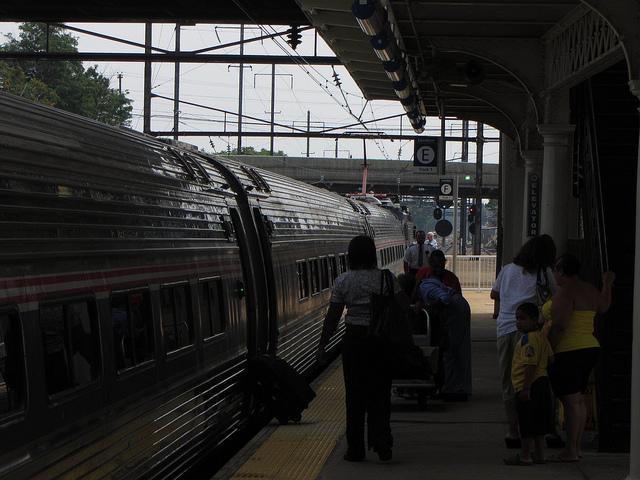How many trains are in the photo?
Give a very brief answer. 1. How many suitcases are in the photo?
Give a very brief answer. 1. How many people are there?
Give a very brief answer. 5. How many people (in front and focus of the photo) have no birds on their shoulders?
Give a very brief answer. 0. 